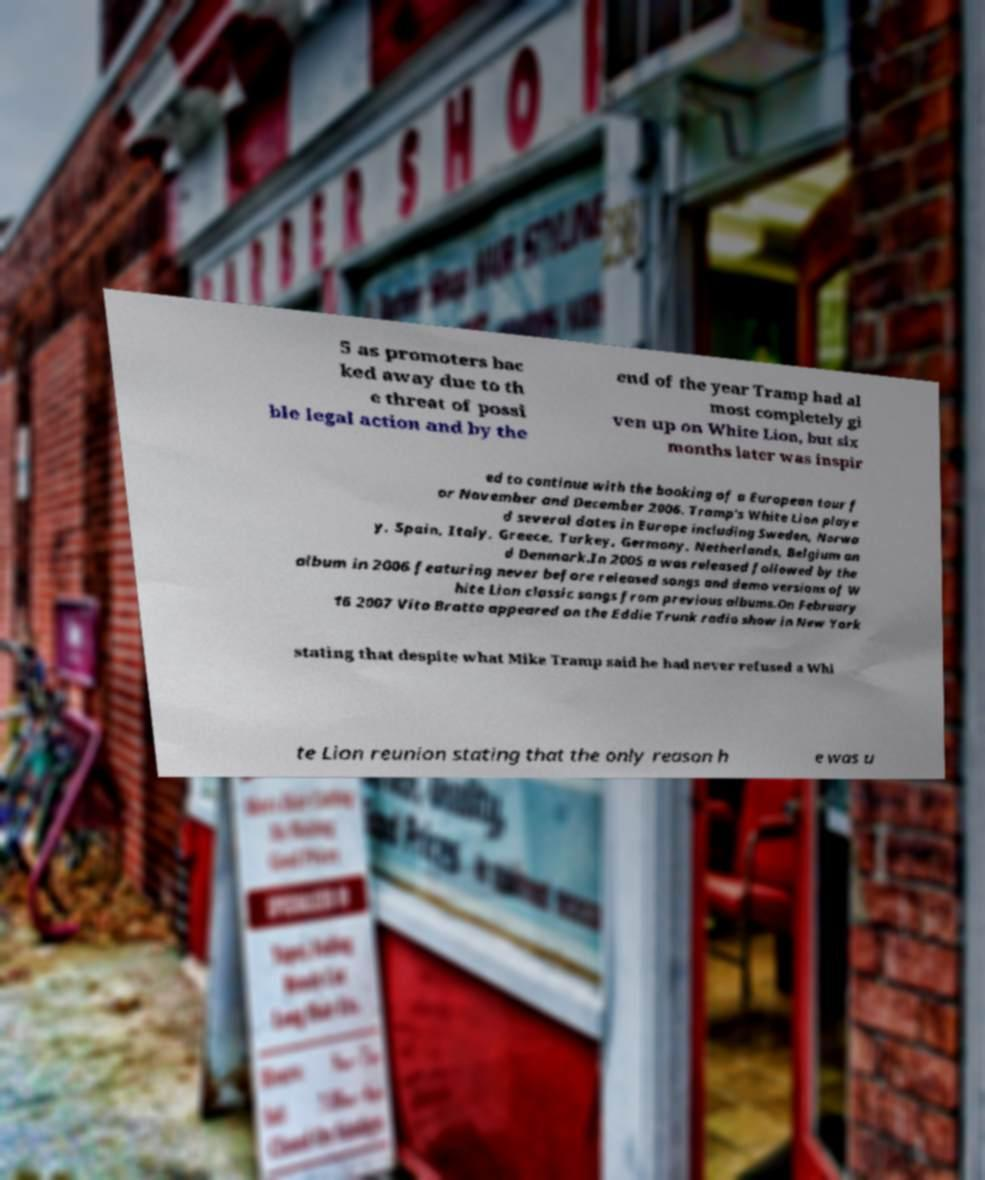Can you read and provide the text displayed in the image?This photo seems to have some interesting text. Can you extract and type it out for me? 5 as promoters bac ked away due to th e threat of possi ble legal action and by the end of the year Tramp had al most completely gi ven up on White Lion, but six months later was inspir ed to continue with the booking of a European tour f or November and December 2006. Tramp's White Lion playe d several dates in Europe including Sweden, Norwa y, Spain, Italy, Greece, Turkey, Germany, Netherlands, Belgium an d Denmark.In 2005 a was released followed by the album in 2006 featuring never before released songs and demo versions of W hite Lion classic songs from previous albums.On February 16 2007 Vito Bratta appeared on the Eddie Trunk radio show in New York stating that despite what Mike Tramp said he had never refused a Whi te Lion reunion stating that the only reason h e was u 